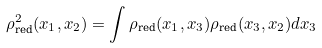<formula> <loc_0><loc_0><loc_500><loc_500>\rho ^ { 2 } _ { \text {red} } ( x _ { 1 } , x _ { 2 } ) = \int \rho _ { \text {red} } ( x _ { 1 } , x _ { 3 } ) \rho _ { \text {red} } ( x _ { 3 } , x _ { 2 } ) d x _ { 3 }</formula> 